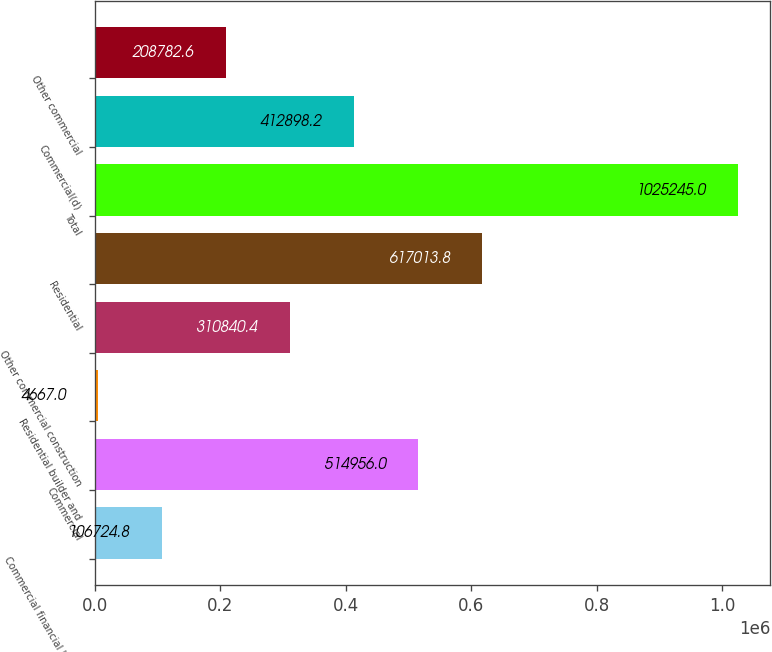Convert chart to OTSL. <chart><loc_0><loc_0><loc_500><loc_500><bar_chart><fcel>Commercial financial leasing<fcel>Commercial<fcel>Residential builder and<fcel>Other commercial construction<fcel>Residential<fcel>Total<fcel>Commercial(d)<fcel>Other commercial<nl><fcel>106725<fcel>514956<fcel>4667<fcel>310840<fcel>617014<fcel>1.02524e+06<fcel>412898<fcel>208783<nl></chart> 